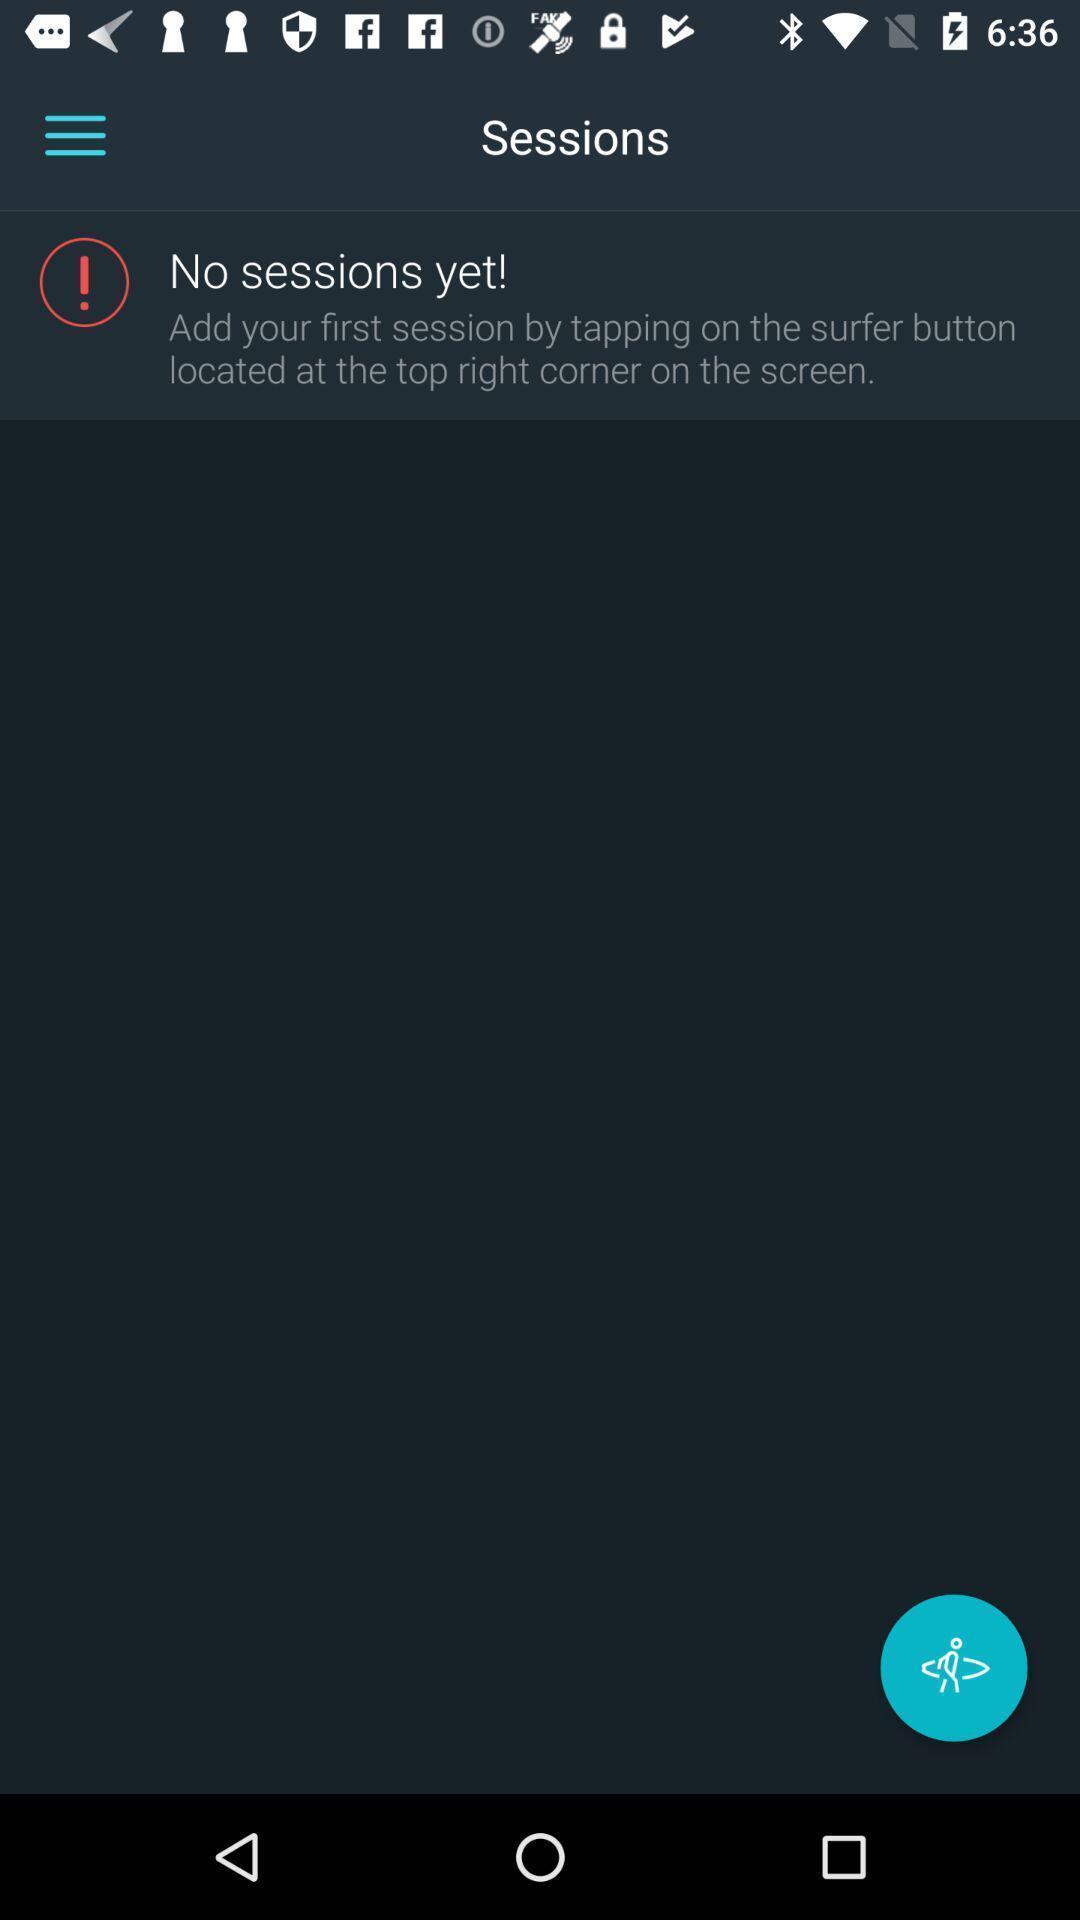Provide a detailed account of this screenshot. Screen shows sessions. 